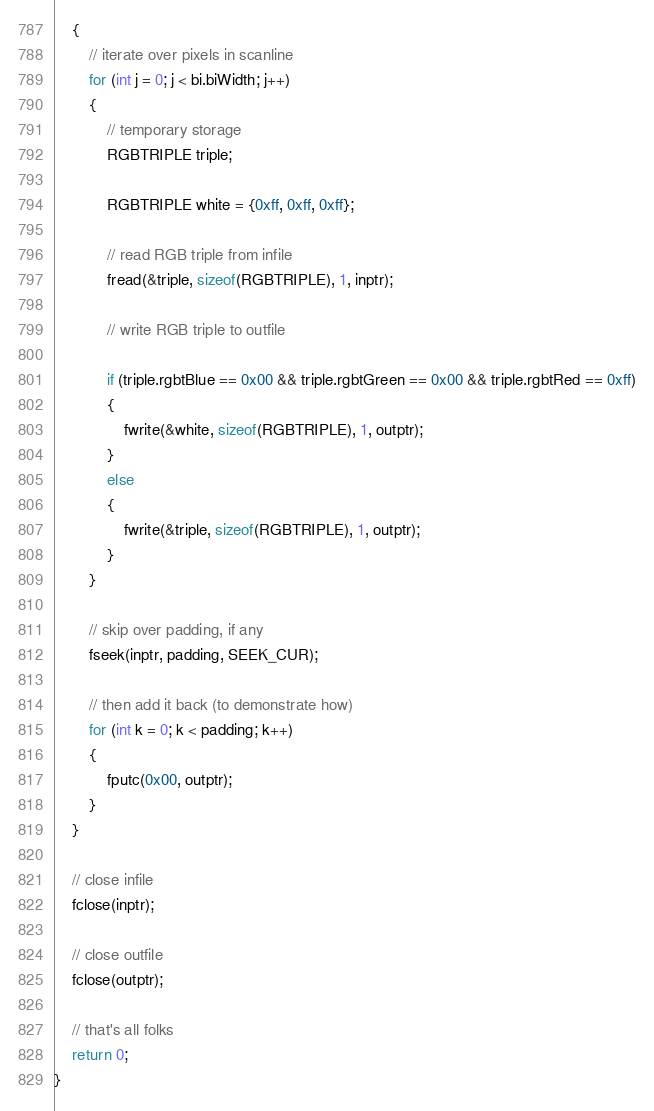Convert code to text. <code><loc_0><loc_0><loc_500><loc_500><_C_>    {
        // iterate over pixels in scanline
        for (int j = 0; j < bi.biWidth; j++)
        {
            // temporary storage
            RGBTRIPLE triple;
            
            RGBTRIPLE white = {0xff, 0xff, 0xff};

            // read RGB triple from infile
            fread(&triple, sizeof(RGBTRIPLE), 1, inptr);

            // write RGB triple to outfile
            
            if (triple.rgbtBlue == 0x00 && triple.rgbtGreen == 0x00 && triple.rgbtRed == 0xff)
            {
                fwrite(&white, sizeof(RGBTRIPLE), 1, outptr);
            }
            else
            {
                fwrite(&triple, sizeof(RGBTRIPLE), 1, outptr);
            }
        }

        // skip over padding, if any
        fseek(inptr, padding, SEEK_CUR);

        // then add it back (to demonstrate how)
        for (int k = 0; k < padding; k++)
        {
            fputc(0x00, outptr);
        }
    }

    // close infile
    fclose(inptr);

    // close outfile
    fclose(outptr);

    // that's all folks
    return 0;
}
</code> 